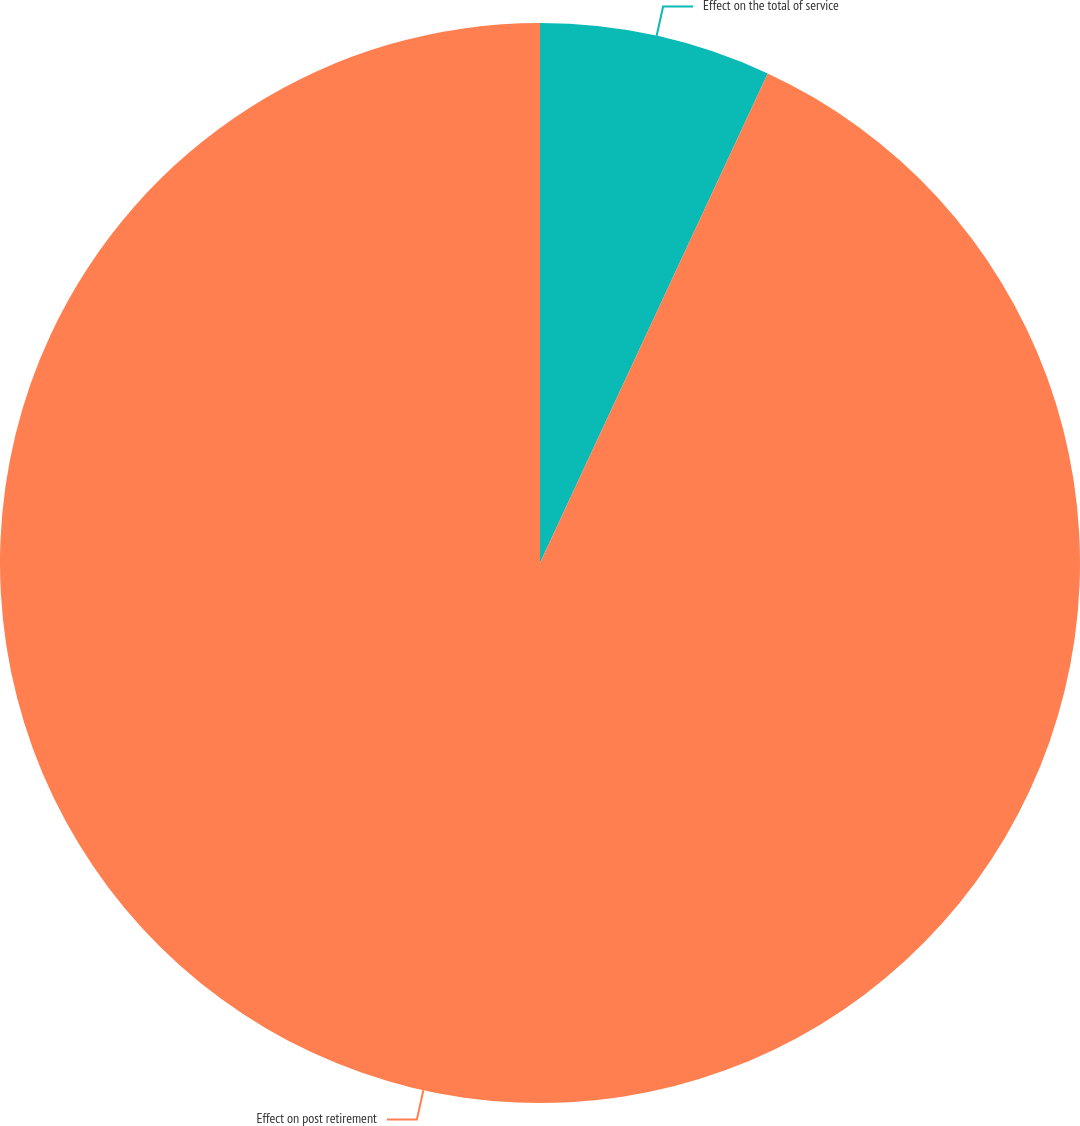Convert chart to OTSL. <chart><loc_0><loc_0><loc_500><loc_500><pie_chart><fcel>Effect on the total of service<fcel>Effect on post retirement<nl><fcel>6.93%<fcel>93.07%<nl></chart> 